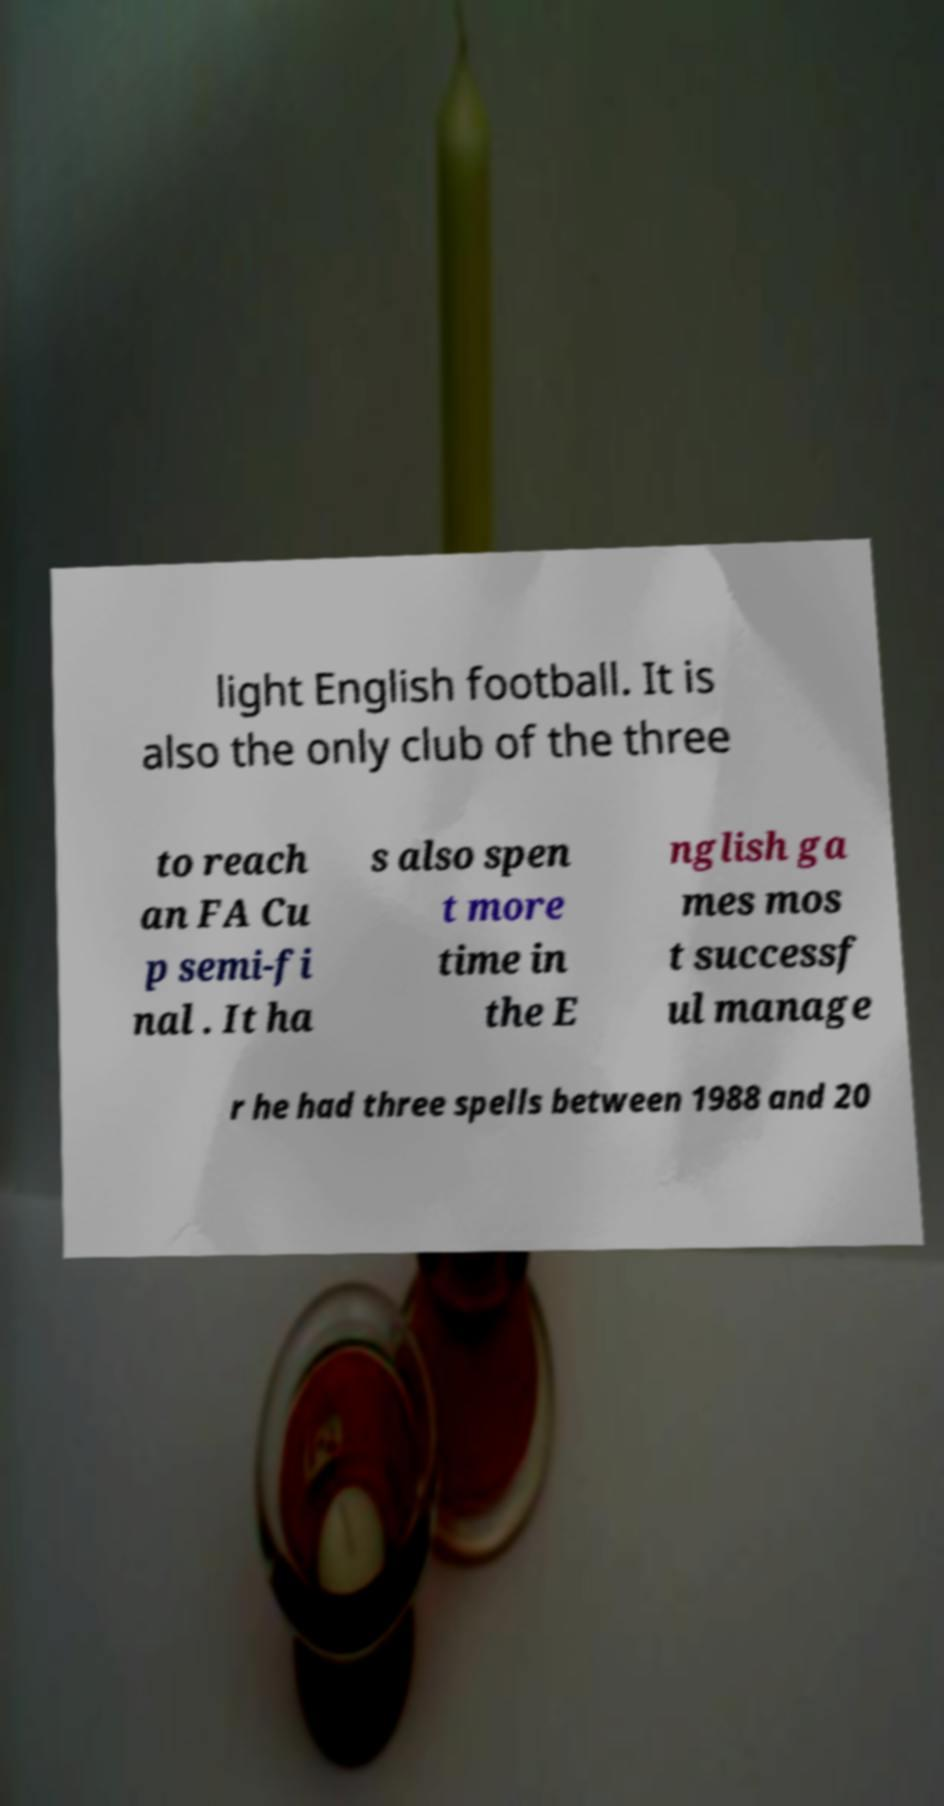Please read and relay the text visible in this image. What does it say? light English football. It is also the only club of the three to reach an FA Cu p semi-fi nal . It ha s also spen t more time in the E nglish ga mes mos t successf ul manage r he had three spells between 1988 and 20 